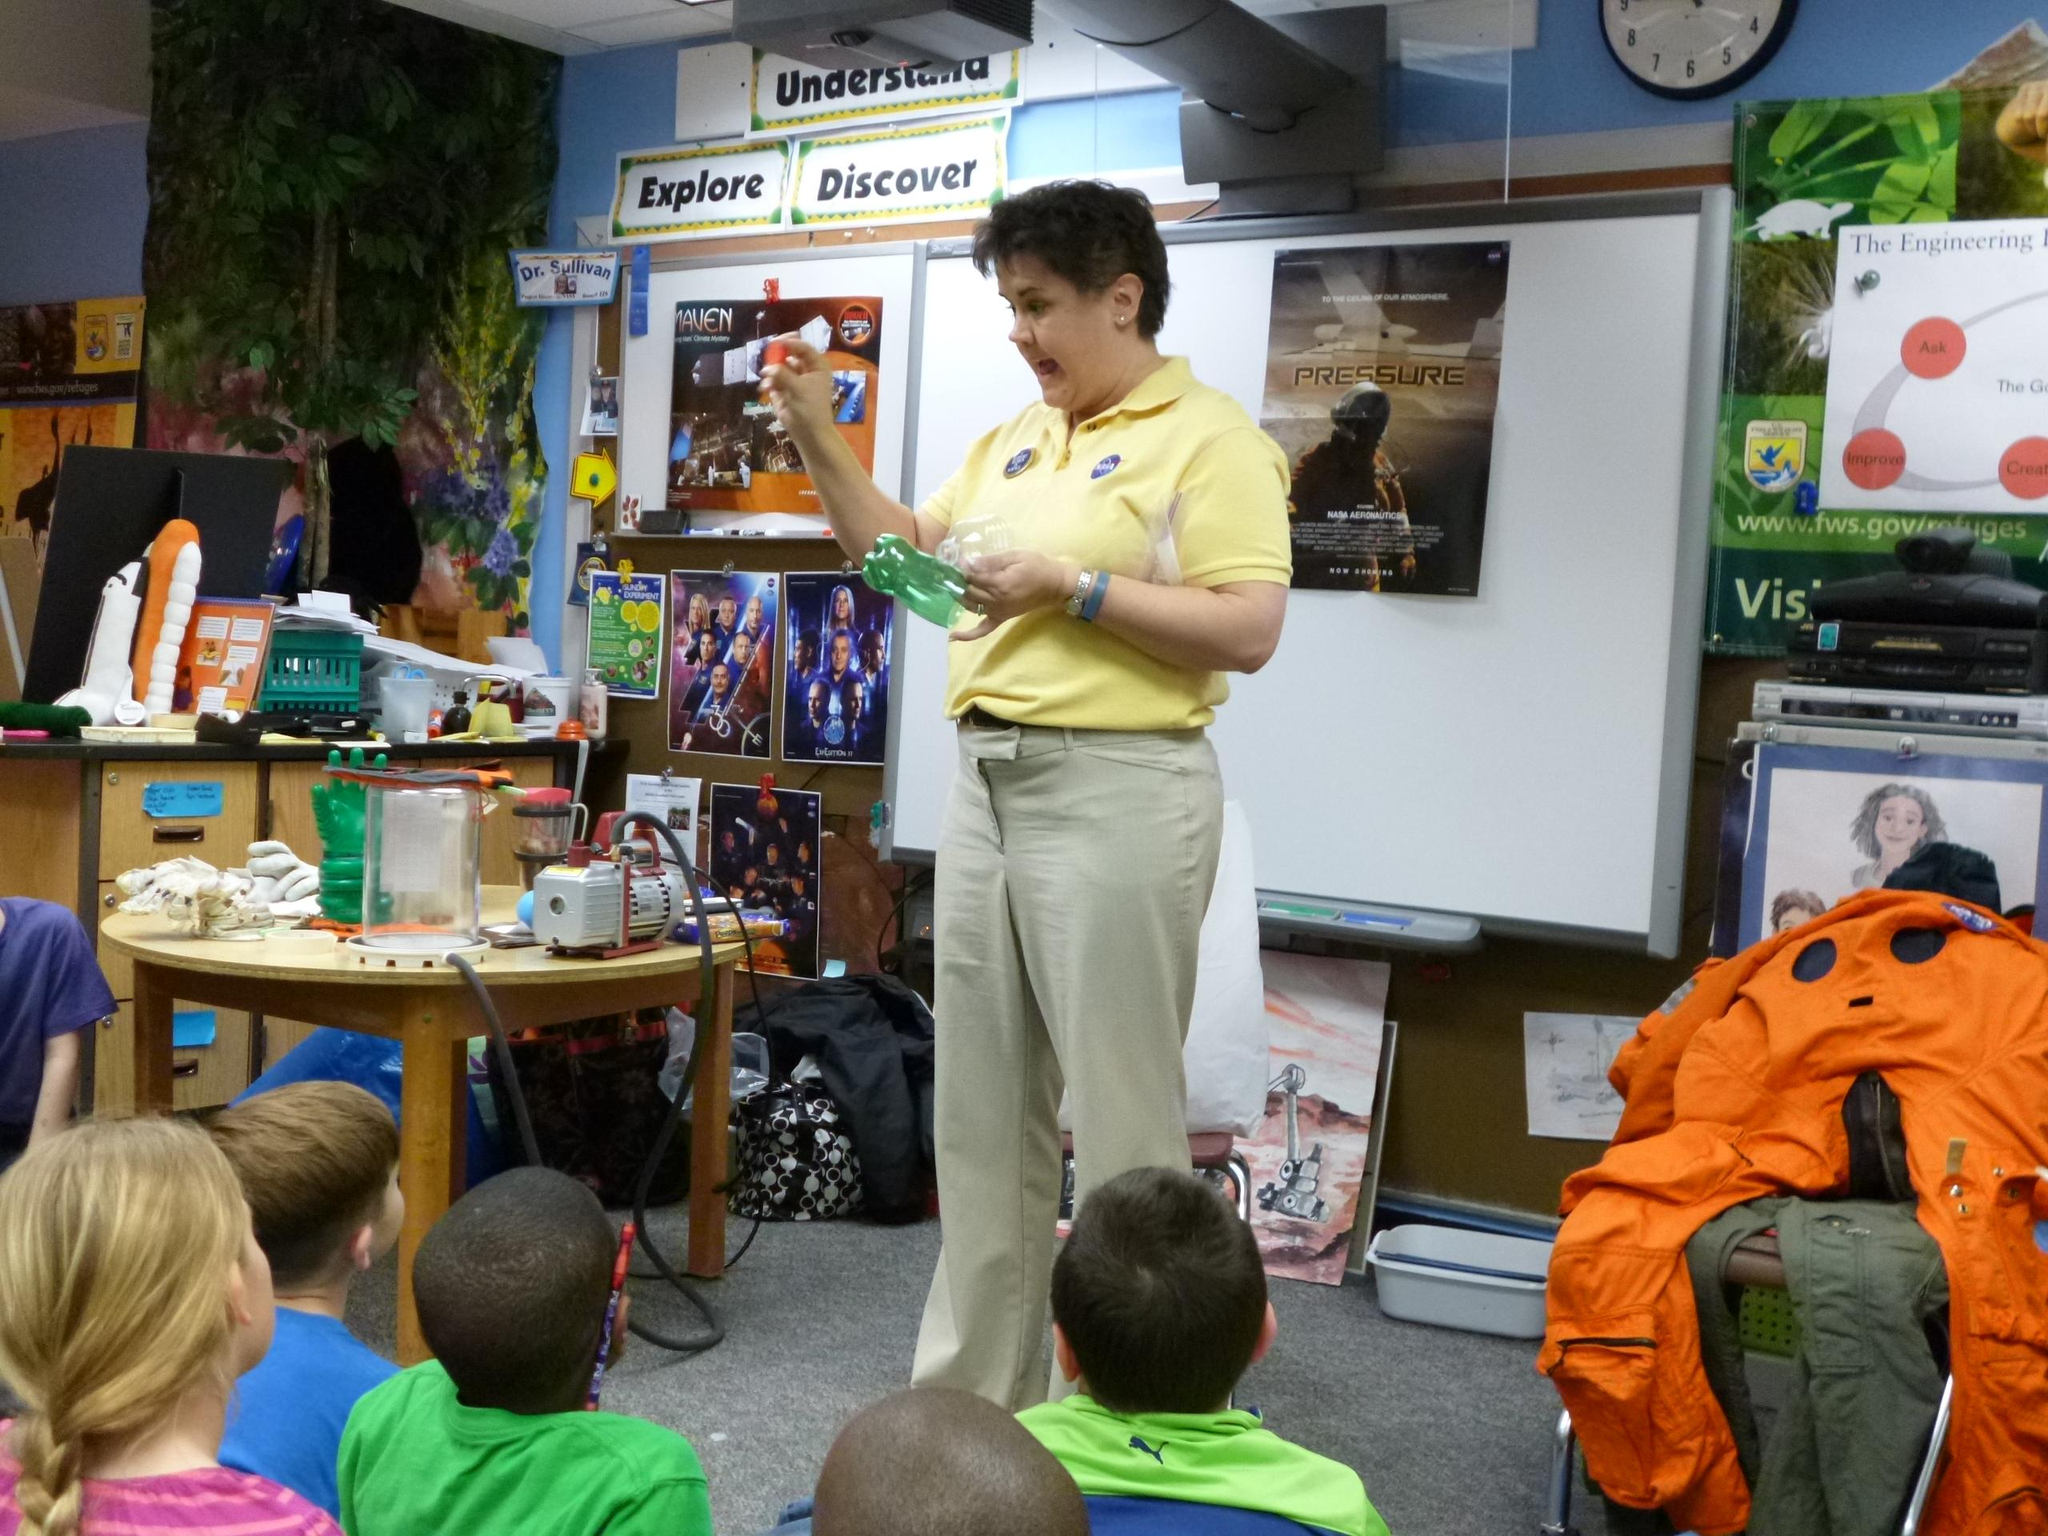Who is present in the image? There is a woman in the image. What is the woman doing in the image? The woman is standing in the image. What is the woman holding in the image? The woman is holding a bottle in the image. Who else is present in the image besides the woman? There are children seated in the image. What else can be seen on the table in the image? There are bottles on the table in the image. How many chickens are visible in the image? There are no chickens present in the image. What type of wall can be seen in the image? There is no wall visible in the image. 